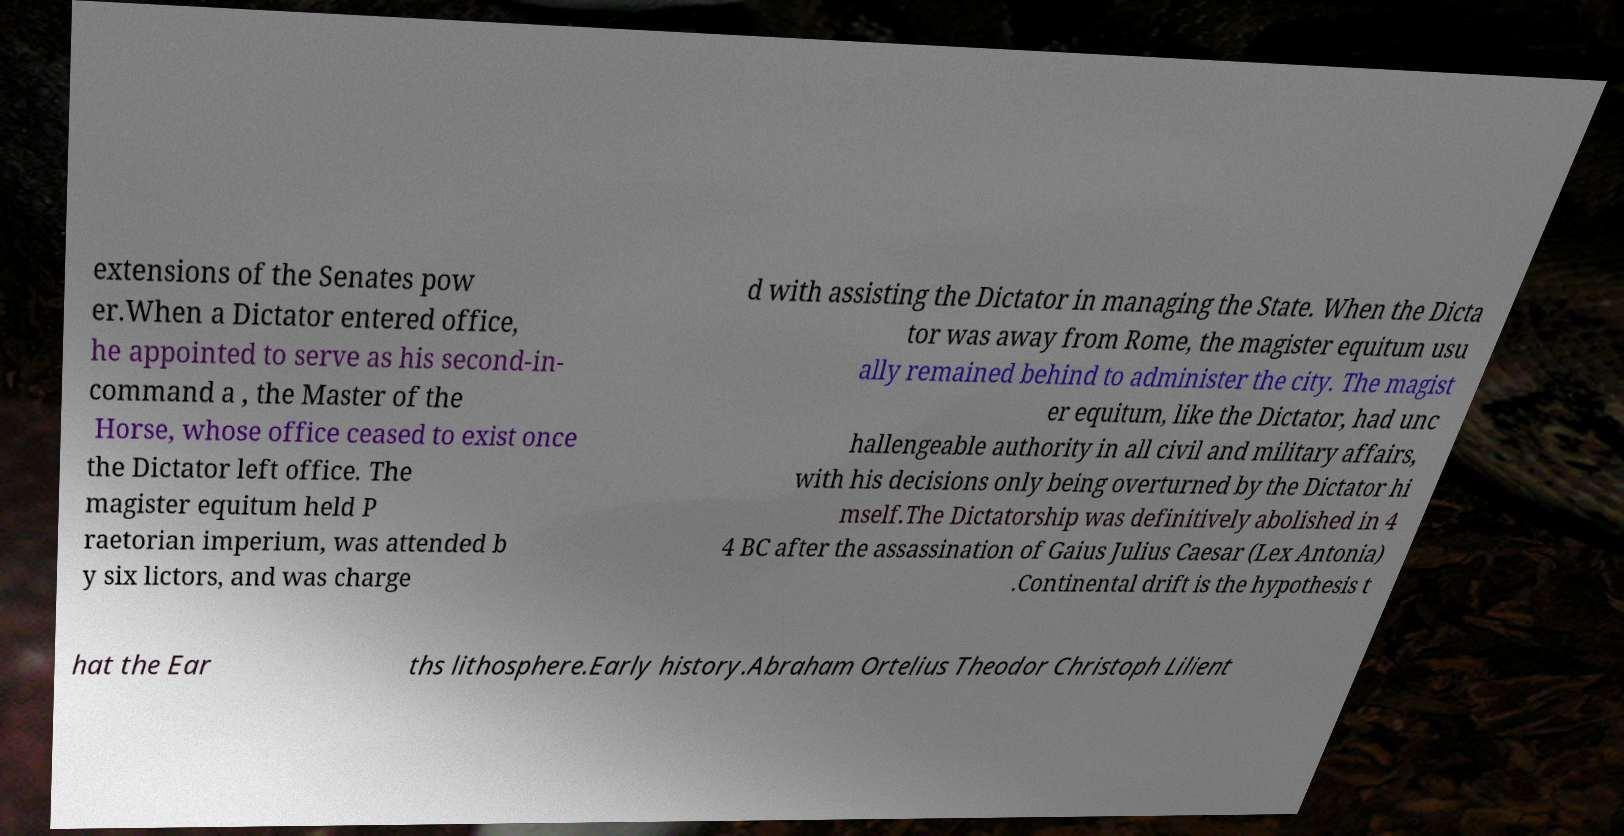I need the written content from this picture converted into text. Can you do that? extensions of the Senates pow er.When a Dictator entered office, he appointed to serve as his second-in- command a , the Master of the Horse, whose office ceased to exist once the Dictator left office. The magister equitum held P raetorian imperium, was attended b y six lictors, and was charge d with assisting the Dictator in managing the State. When the Dicta tor was away from Rome, the magister equitum usu ally remained behind to administer the city. The magist er equitum, like the Dictator, had unc hallengeable authority in all civil and military affairs, with his decisions only being overturned by the Dictator hi mself.The Dictatorship was definitively abolished in 4 4 BC after the assassination of Gaius Julius Caesar (Lex Antonia) .Continental drift is the hypothesis t hat the Ear ths lithosphere.Early history.Abraham Ortelius Theodor Christoph Lilient 